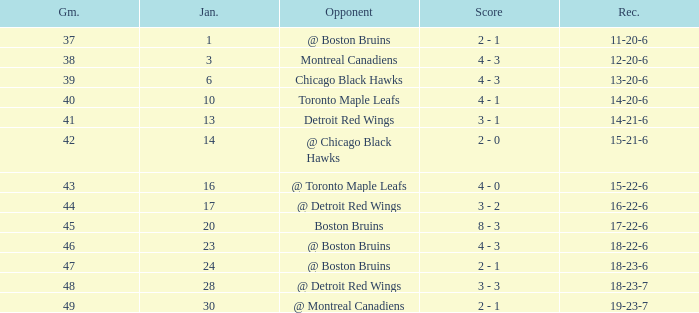What was the total number of games on January 20? 1.0. Could you parse the entire table? {'header': ['Gm.', 'Jan.', 'Opponent', 'Score', 'Rec.'], 'rows': [['37', '1', '@ Boston Bruins', '2 - 1', '11-20-6'], ['38', '3', 'Montreal Canadiens', '4 - 3', '12-20-6'], ['39', '6', 'Chicago Black Hawks', '4 - 3', '13-20-6'], ['40', '10', 'Toronto Maple Leafs', '4 - 1', '14-20-6'], ['41', '13', 'Detroit Red Wings', '3 - 1', '14-21-6'], ['42', '14', '@ Chicago Black Hawks', '2 - 0', '15-21-6'], ['43', '16', '@ Toronto Maple Leafs', '4 - 0', '15-22-6'], ['44', '17', '@ Detroit Red Wings', '3 - 2', '16-22-6'], ['45', '20', 'Boston Bruins', '8 - 3', '17-22-6'], ['46', '23', '@ Boston Bruins', '4 - 3', '18-22-6'], ['47', '24', '@ Boston Bruins', '2 - 1', '18-23-6'], ['48', '28', '@ Detroit Red Wings', '3 - 3', '18-23-7'], ['49', '30', '@ Montreal Canadiens', '2 - 1', '19-23-7']]} 